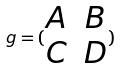<formula> <loc_0><loc_0><loc_500><loc_500>g = ( \begin{matrix} A & B \\ C & D \end{matrix} )</formula> 